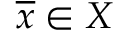<formula> <loc_0><loc_0><loc_500><loc_500>{ \overline { x } } \in X</formula> 